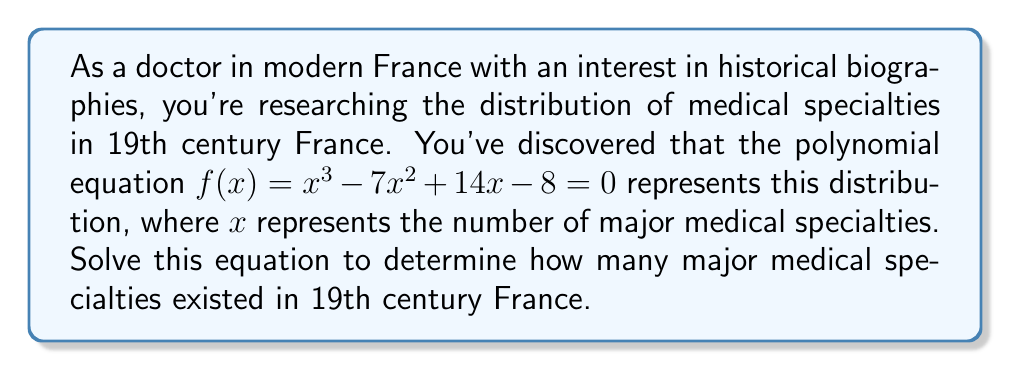Provide a solution to this math problem. To solve this polynomial equation, we'll use factoring techniques:

1) First, let's check if there are any rational roots using the rational root theorem. The possible rational roots are the factors of the constant term: ±1, ±2, ±4, ±8.

2) Testing these values, we find that $f(1) = 0$. So $(x-1)$ is a factor.

3) We can use polynomial long division to divide $f(x)$ by $(x-1)$:

   $x^3 - 7x^2 + 14x - 8 = (x-1)(x^2 - 6x + 8)$

4) Now we need to factor the quadratic term $x^2 - 6x + 8$:

   The factors of 8 that add up to -6 are -2 and -4.

   So, $x^2 - 6x + 8 = (x-2)(x-4)$

5) Therefore, the complete factorization is:

   $f(x) = (x-1)(x-2)(x-4) = 0$

6) The solutions to this equation are the values that make each factor equal to zero:

   $x = 1$ or $x = 2$ or $x = 4$

7) Since $x$ represents the number of major medical specialties, and it must be a positive integer, all these solutions are valid in the context of our problem.

8) The largest value, 4, represents the total number of major medical specialties in 19th century France according to this model.
Answer: The equation has three solutions: 1, 2, and 4. In the context of medical specialties in 19th century France, the answer is 4 major medical specialties. 